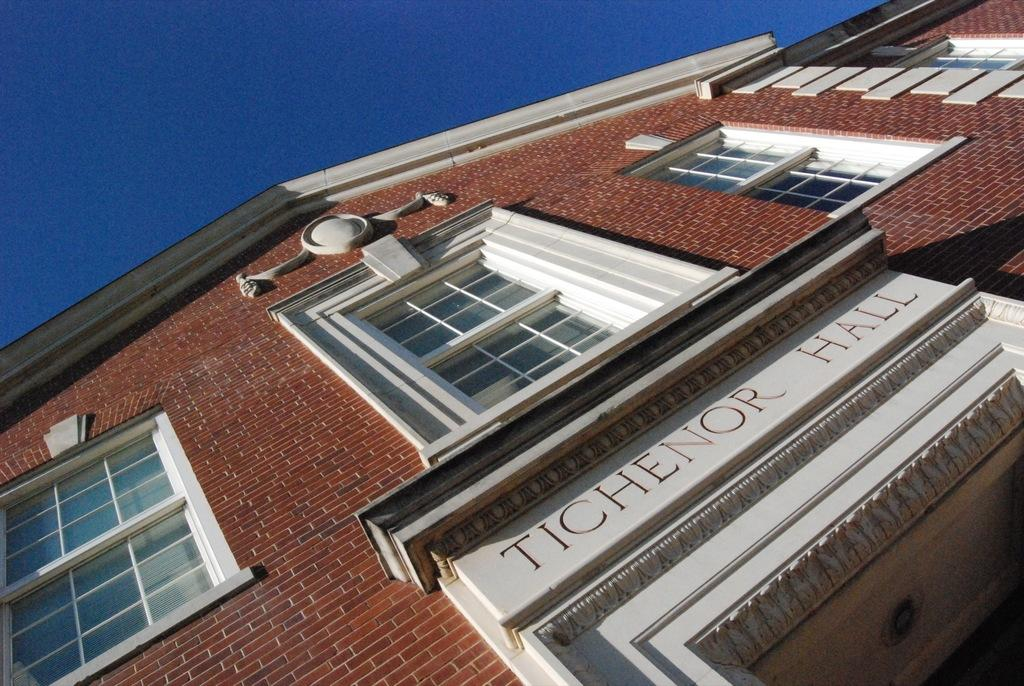What is the main subject of the picture? The main subject of the picture is a building. Can you describe any specific features of the building? Yes, the building has a name plate. What is the condition of the sky in the picture? The sky is clear in the picture. How many bags can be seen hanging from the building in the image? There are no bags visible in the image; it only features a building with a name plate and a clear sky. What type of horn is attached to the building in the image? There is no horn present on the building in the image. 